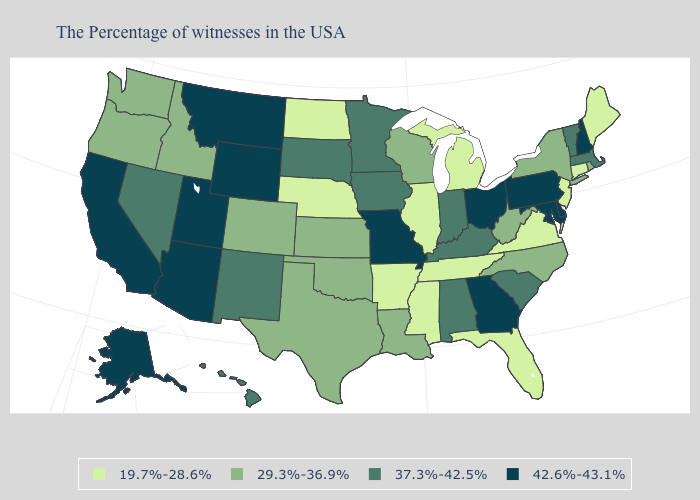Name the states that have a value in the range 42.6%-43.1%?
Short answer required. New Hampshire, Delaware, Maryland, Pennsylvania, Ohio, Georgia, Missouri, Wyoming, Utah, Montana, Arizona, California, Alaska. Which states hav the highest value in the South?
Short answer required. Delaware, Maryland, Georgia. Among the states that border Utah , which have the lowest value?
Concise answer only. Colorado, Idaho. What is the value of Tennessee?
Quick response, please. 19.7%-28.6%. Does the first symbol in the legend represent the smallest category?
Give a very brief answer. Yes. What is the value of Massachusetts?
Short answer required. 37.3%-42.5%. What is the value of Montana?
Give a very brief answer. 42.6%-43.1%. What is the value of Texas?
Write a very short answer. 29.3%-36.9%. What is the value of New Jersey?
Concise answer only. 19.7%-28.6%. What is the value of Oklahoma?
Short answer required. 29.3%-36.9%. What is the value of Minnesota?
Short answer required. 37.3%-42.5%. Does Pennsylvania have a lower value than Arizona?
Give a very brief answer. No. What is the lowest value in states that border Tennessee?
Short answer required. 19.7%-28.6%. Name the states that have a value in the range 37.3%-42.5%?
Write a very short answer. Massachusetts, Vermont, South Carolina, Kentucky, Indiana, Alabama, Minnesota, Iowa, South Dakota, New Mexico, Nevada, Hawaii. Among the states that border Montana , which have the lowest value?
Keep it brief. North Dakota. 